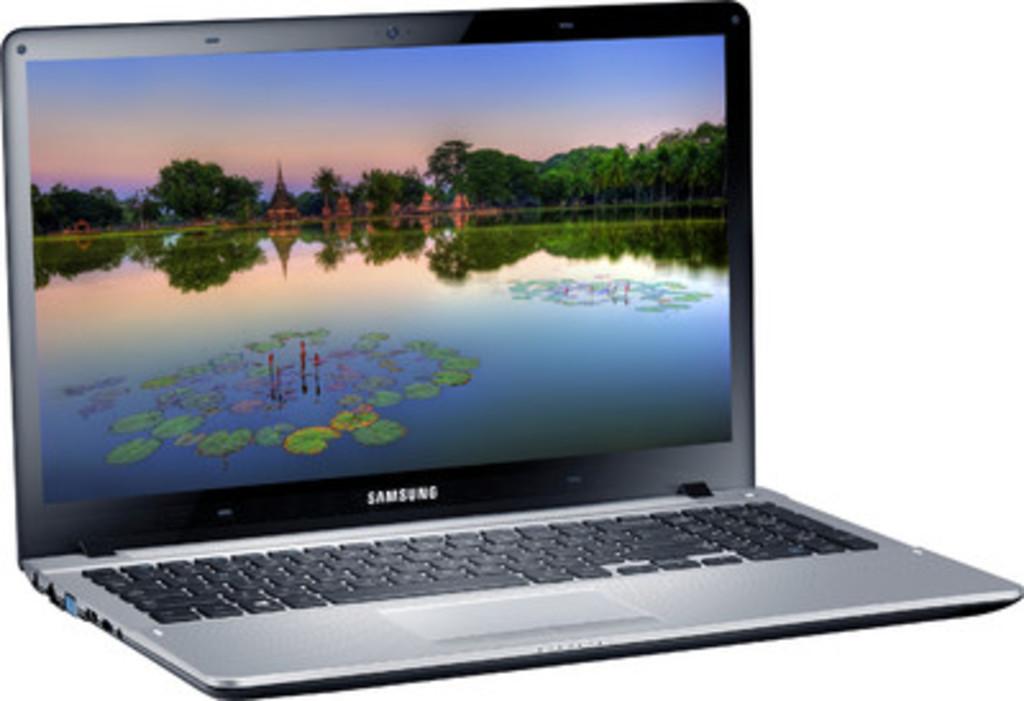What brand of laptop is this?
Make the answer very short. Samsung. 